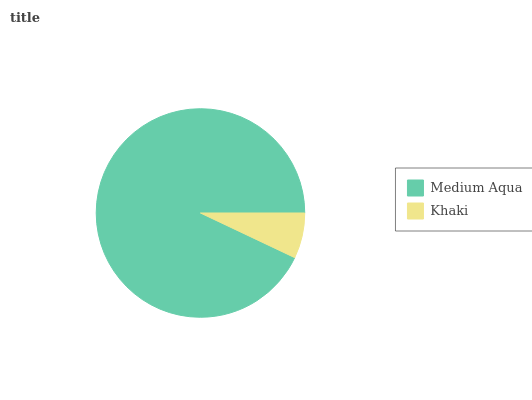Is Khaki the minimum?
Answer yes or no. Yes. Is Medium Aqua the maximum?
Answer yes or no. Yes. Is Khaki the maximum?
Answer yes or no. No. Is Medium Aqua greater than Khaki?
Answer yes or no. Yes. Is Khaki less than Medium Aqua?
Answer yes or no. Yes. Is Khaki greater than Medium Aqua?
Answer yes or no. No. Is Medium Aqua less than Khaki?
Answer yes or no. No. Is Medium Aqua the high median?
Answer yes or no. Yes. Is Khaki the low median?
Answer yes or no. Yes. Is Khaki the high median?
Answer yes or no. No. Is Medium Aqua the low median?
Answer yes or no. No. 